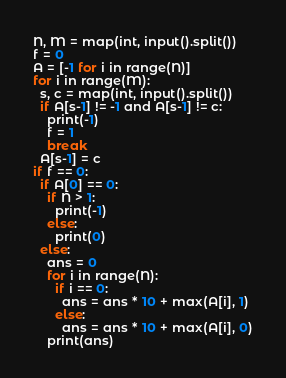Convert code to text. <code><loc_0><loc_0><loc_500><loc_500><_Python_>N, M = map(int, input().split())
f = 0
A = [-1 for i in range(N)]
for i in range(M):
  s, c = map(int, input().split())
  if A[s-1] != -1 and A[s-1] != c:
    print(-1)
    f = 1
    break
  A[s-1] = c
if f == 0:
  if A[0] == 0:
    if N > 1:
      print(-1)
    else:
      print(0)
  else:
    ans = 0
    for i in range(N):
      if i == 0:
        ans = ans * 10 + max(A[i], 1)
      else:
        ans = ans * 10 + max(A[i], 0)
    print(ans)</code> 